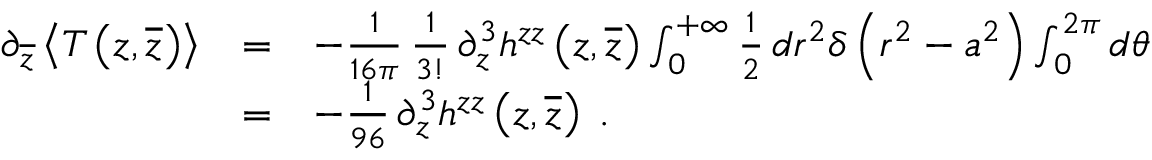Convert formula to latex. <formula><loc_0><loc_0><loc_500><loc_500>\begin{array} { l c l } { { \partial _ { \overline { z } } \left < T \left ( z , \overline { z } \right ) \right > } } & { = } & { { - { \frac { 1 } { 1 6 \pi } } \, { \frac { 1 } { 3 ! } } \, \partial _ { z } ^ { 3 } h ^ { z z } \left ( z , \overline { z } \right ) \int _ { 0 } ^ { + \infty } { \frac { 1 } { 2 } } \, d r ^ { 2 } \delta \left ( r ^ { 2 } - a ^ { 2 } \right ) \int _ { 0 } ^ { 2 \pi } d \theta } } \\ { \ } & { = } & { { - { \frac { 1 } { 9 6 } } \, \partial _ { z } ^ { 3 } h ^ { z z } \left ( z , \overline { z } \right ) \, . } } \end{array}</formula> 